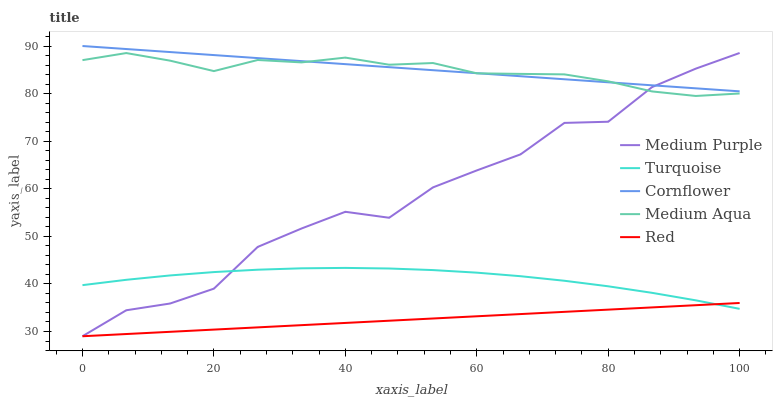Does Turquoise have the minimum area under the curve?
Answer yes or no. No. Does Turquoise have the maximum area under the curve?
Answer yes or no. No. Is Turquoise the smoothest?
Answer yes or no. No. Is Turquoise the roughest?
Answer yes or no. No. Does Turquoise have the lowest value?
Answer yes or no. No. Does Turquoise have the highest value?
Answer yes or no. No. Is Turquoise less than Cornflower?
Answer yes or no. Yes. Is Cornflower greater than Turquoise?
Answer yes or no. Yes. Does Turquoise intersect Cornflower?
Answer yes or no. No. 